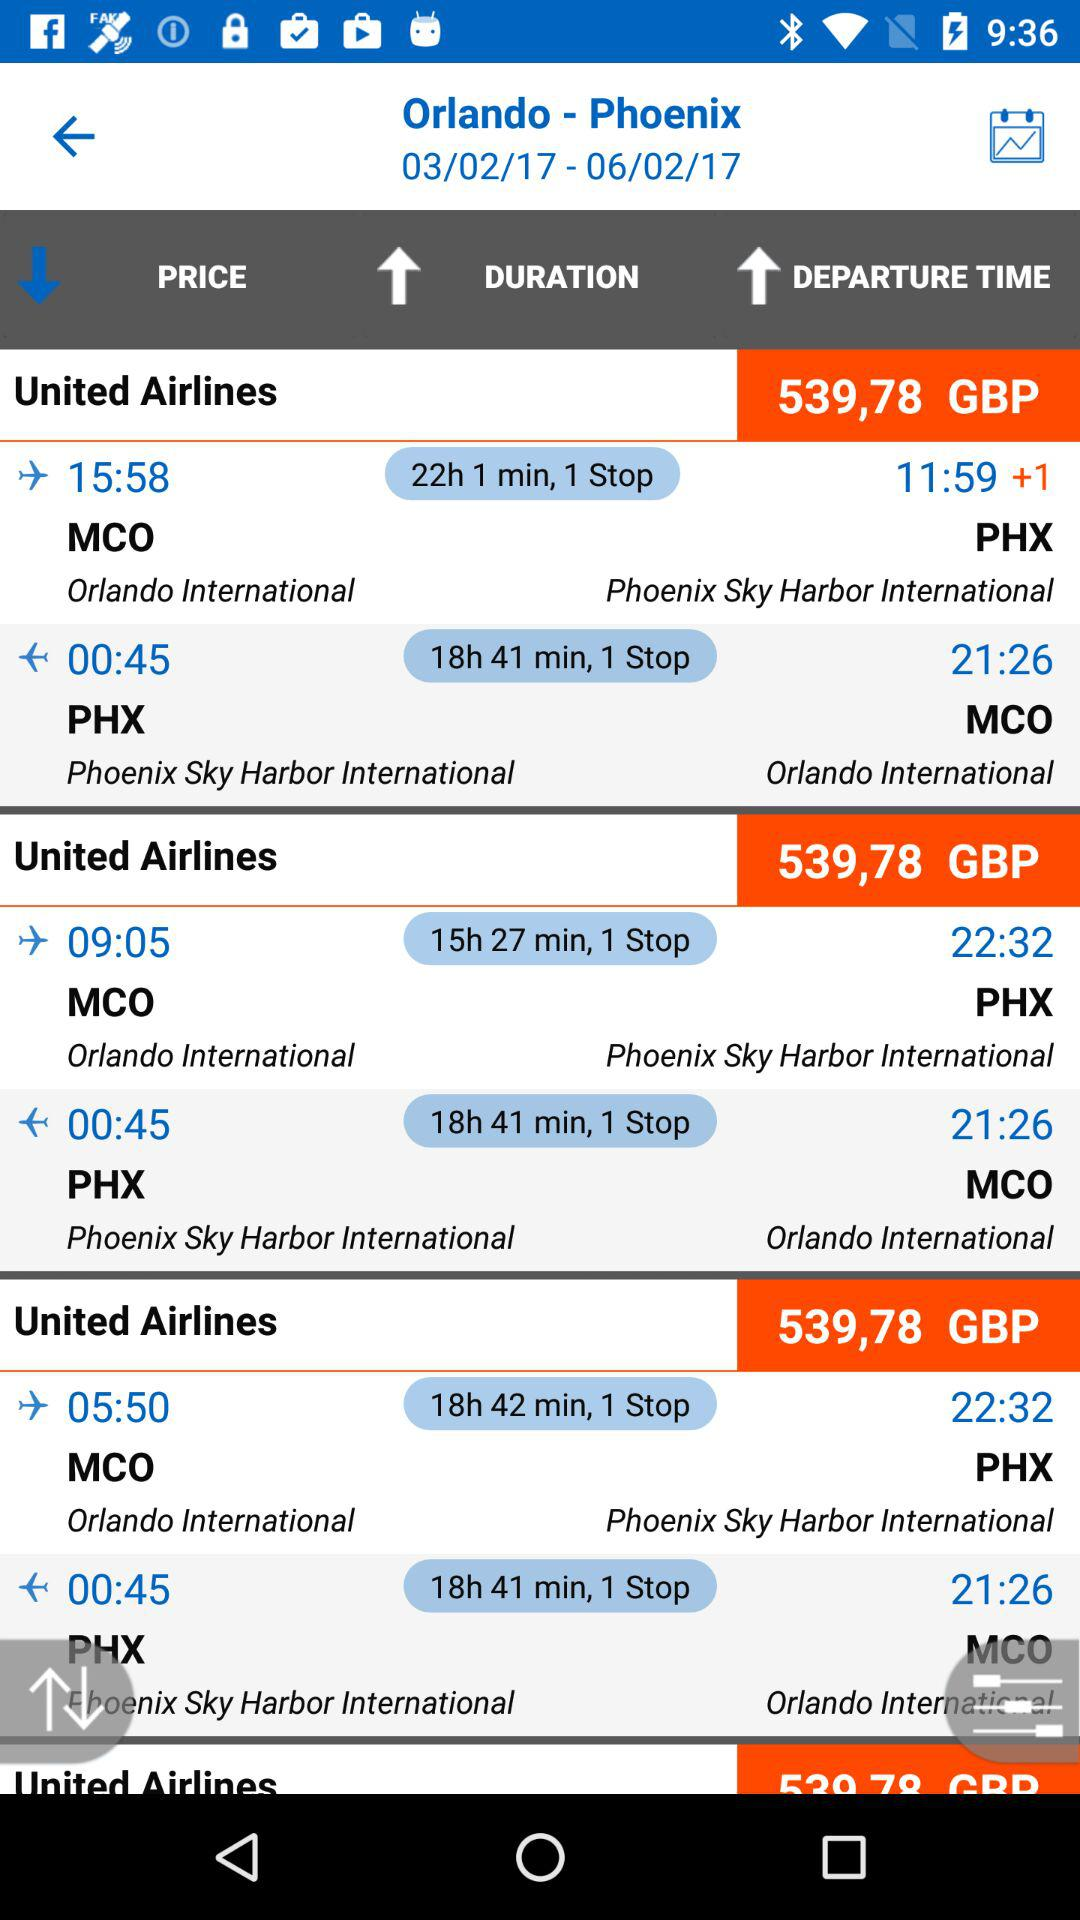What is the price of a round-trip ticket from MCO to PHX? The price of a round-trip ticket from MCO to PHX is 539,78 GBP. 